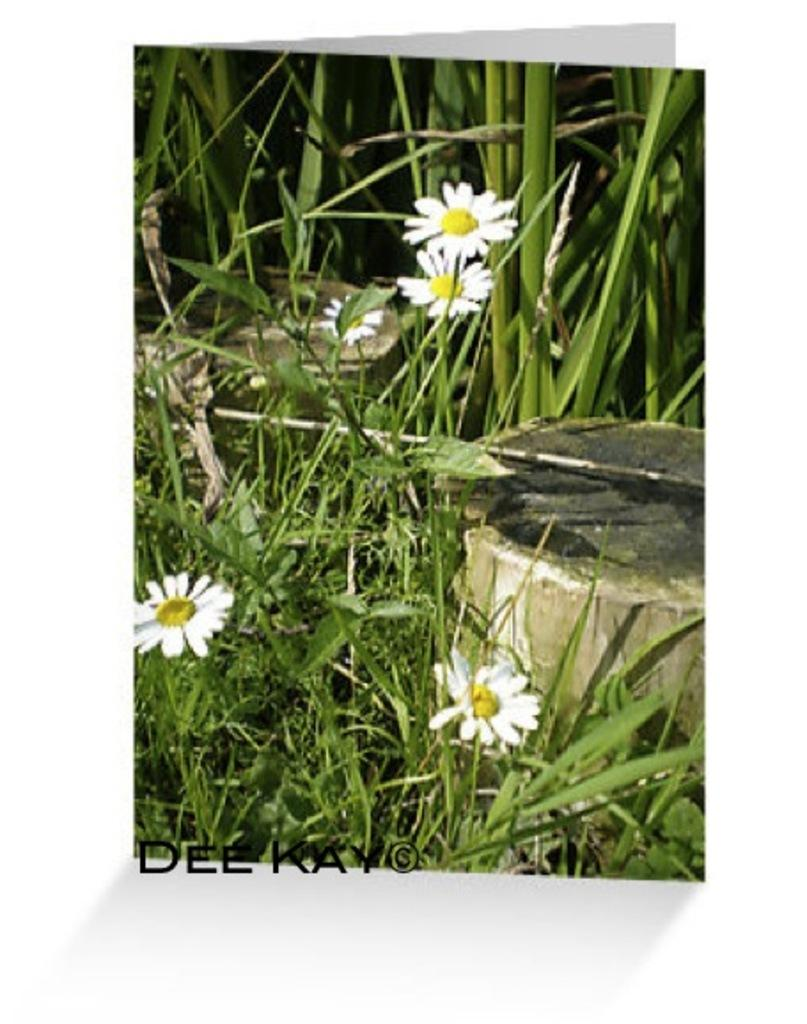What type of plants can be seen in the image? There are plants with flowers in the image. What else is present in the image besides the plants? There are objects in the image. Is there any text visible in the image? Yes, there is text written on the image. Can you describe the goldfish swimming in the image? There are no goldfish present in the image; it features plants with flowers, objects, and text. 